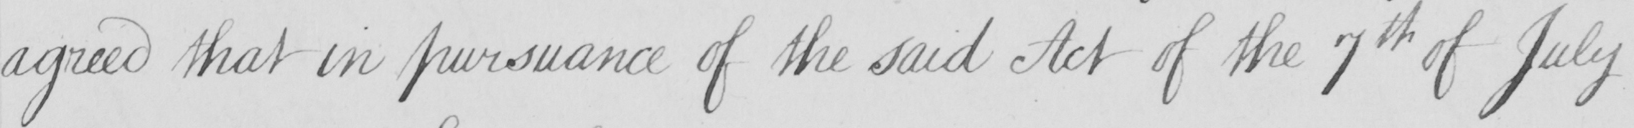What text is written in this handwritten line? agreed that in pursuance of the said Act of the 7th of July 